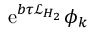Convert formula to latex. <formula><loc_0><loc_0><loc_500><loc_500>e ^ { b \tau \mathcal { L } _ { H _ { 2 } } } \phi _ { k }</formula> 